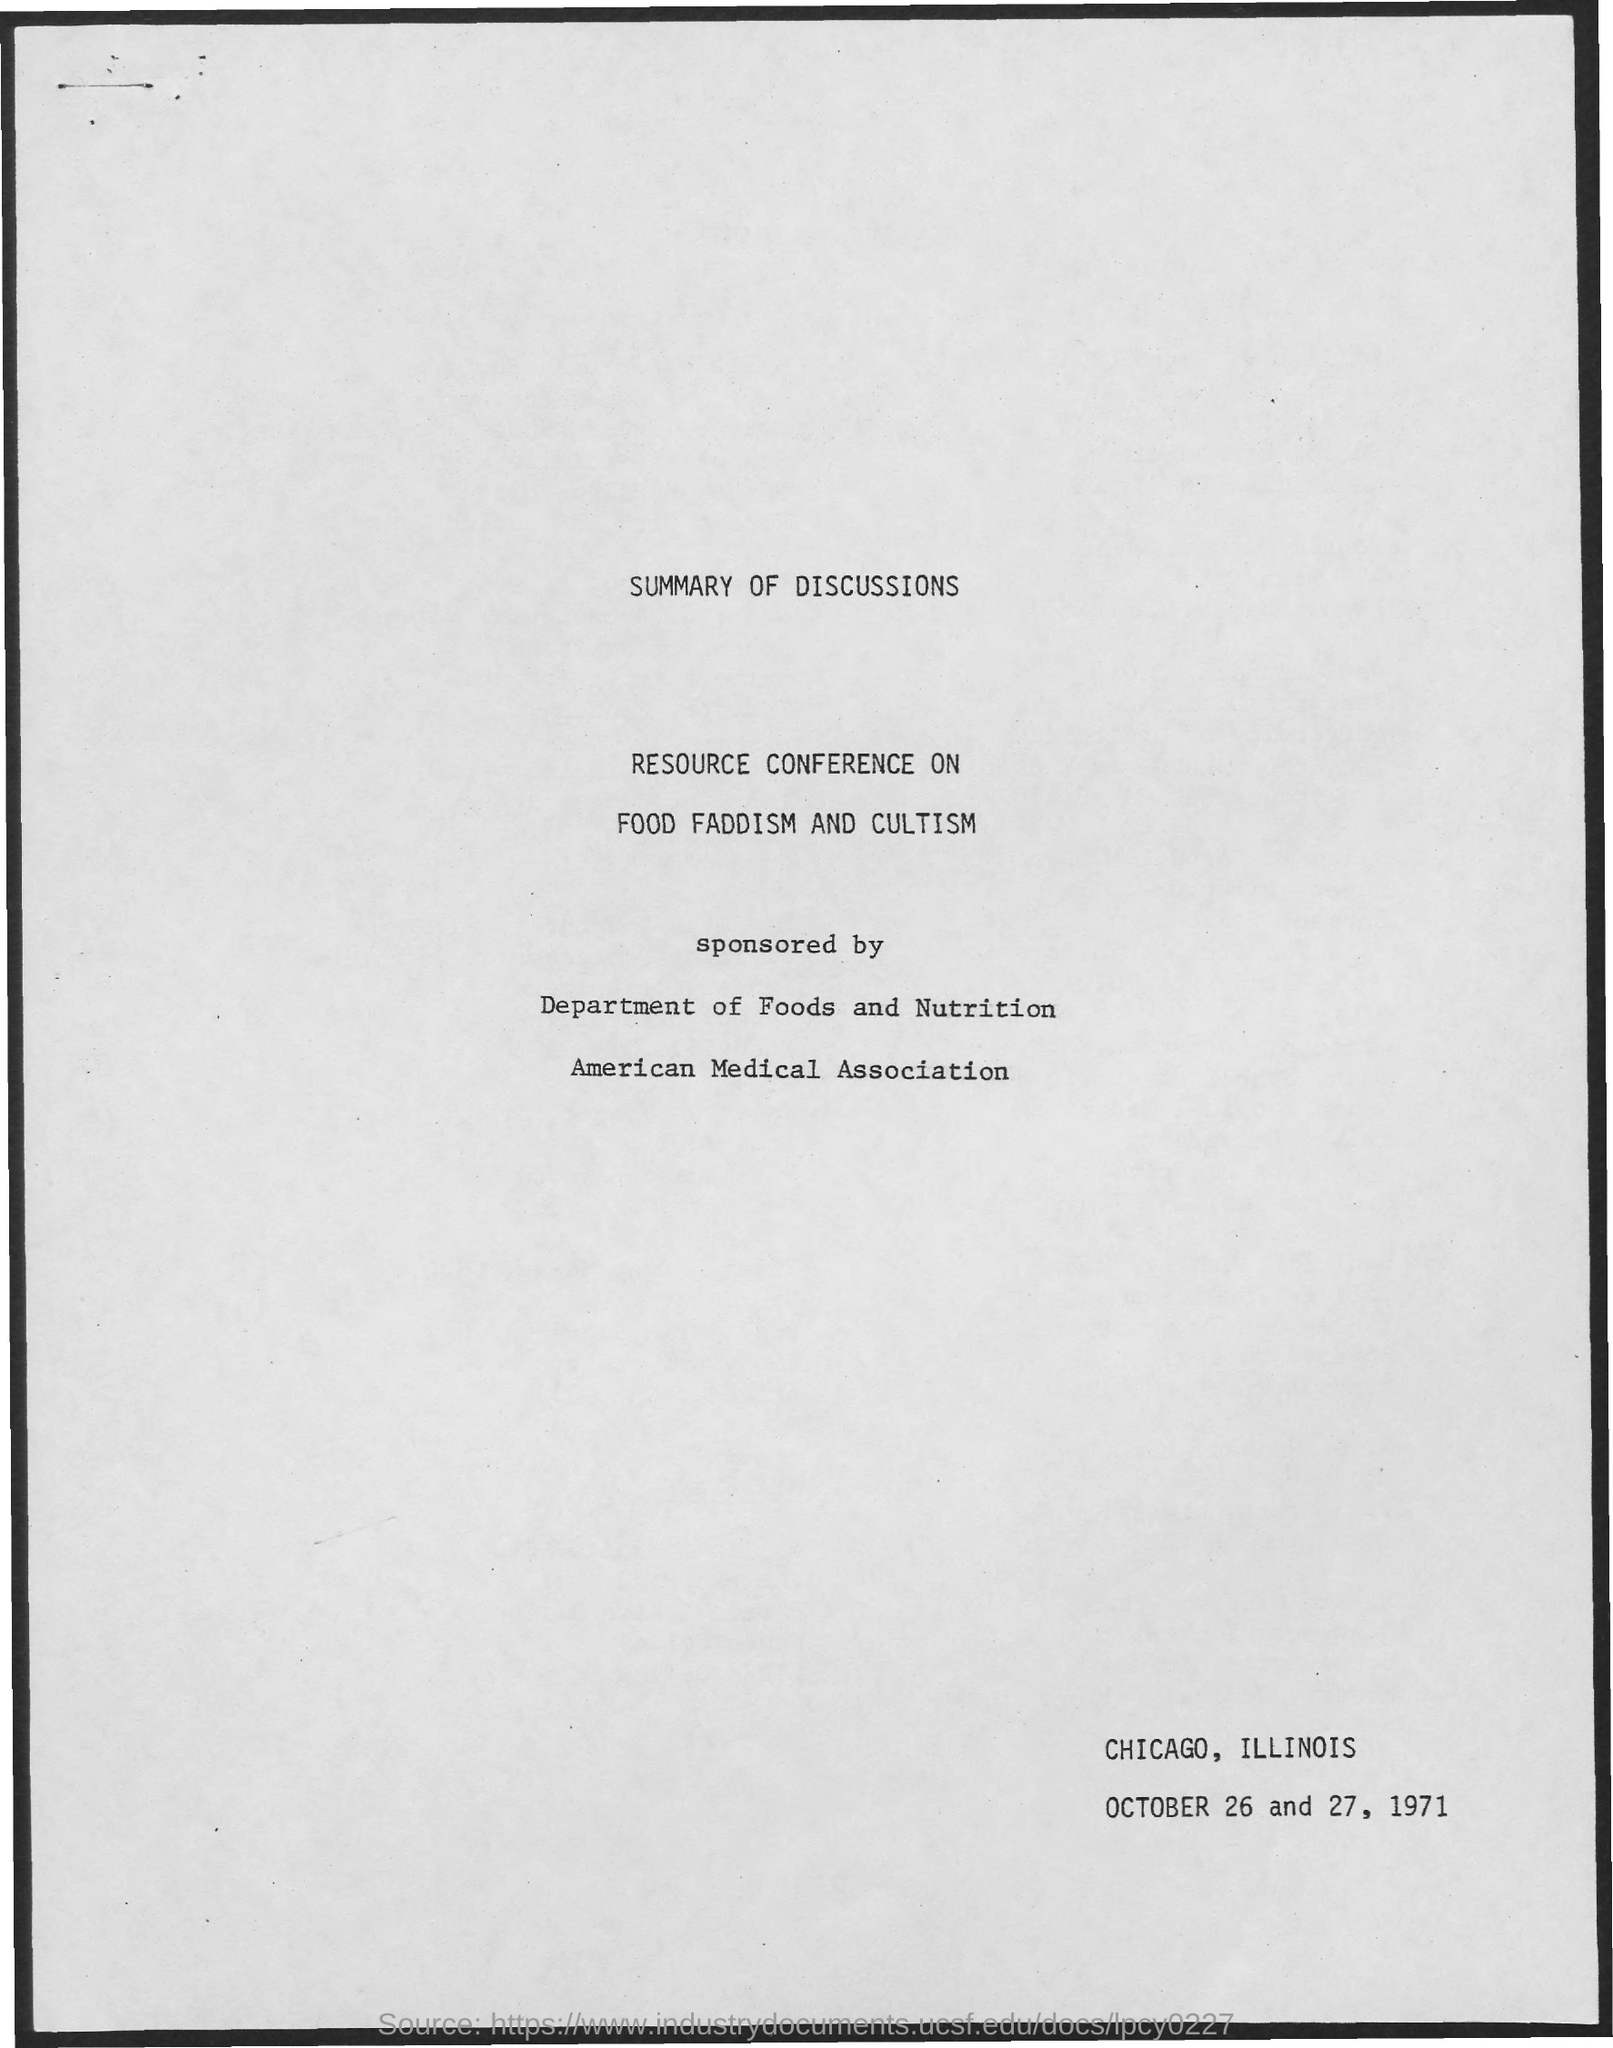What is the heading of document on top?
Offer a very short reply. Summary of Discussions. What is the month mentioned in the document?
Provide a short and direct response. October. 